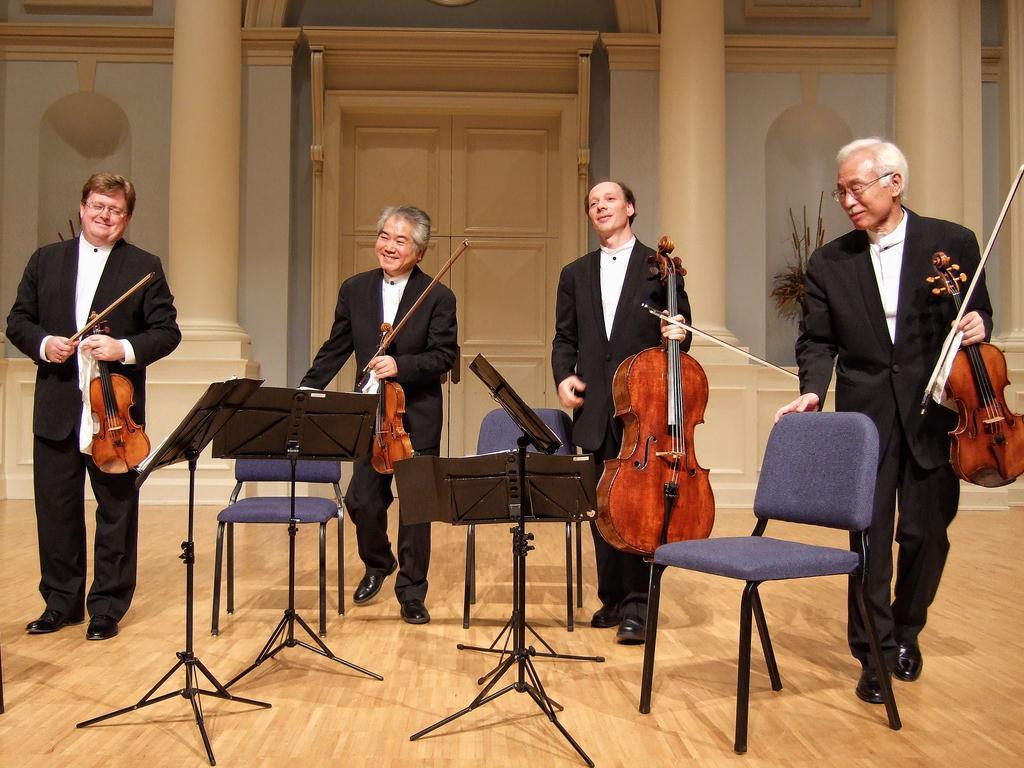Can you describe this image briefly? In this picture there are group of four people, holding violin of different sizes and there are three chairs and there is a wooden floor. 